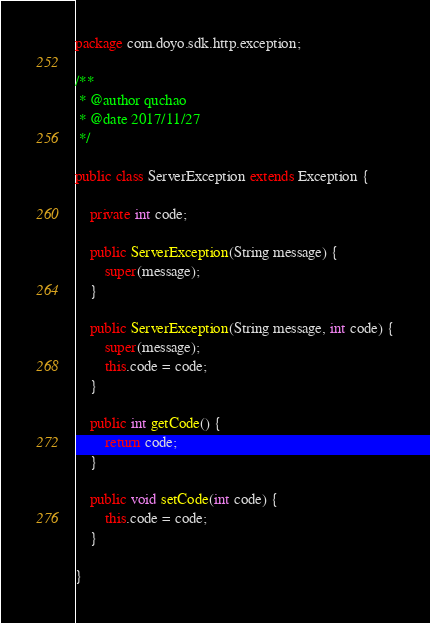<code> <loc_0><loc_0><loc_500><loc_500><_Java_>package com.doyo.sdk.http.exception;

/**
 * @author quchao
 * @date 2017/11/27
 */

public class ServerException extends Exception {

    private int code;

    public ServerException(String message) {
        super(message);
    }

    public ServerException(String message, int code) {
        super(message);
        this.code = code;
    }

    public int getCode() {
        return code;
    }

    public void setCode(int code) {
        this.code = code;
    }

}
</code> 